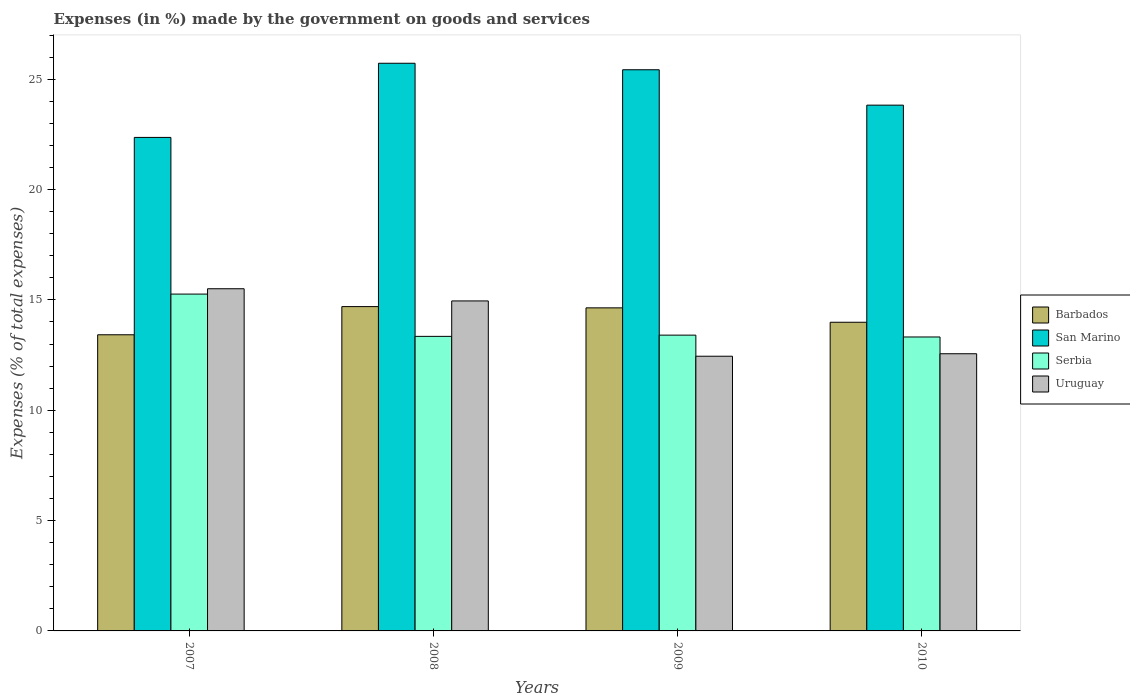How many groups of bars are there?
Keep it short and to the point. 4. Are the number of bars per tick equal to the number of legend labels?
Give a very brief answer. Yes. How many bars are there on the 3rd tick from the right?
Make the answer very short. 4. What is the percentage of expenses made by the government on goods and services in Uruguay in 2008?
Your response must be concise. 14.95. Across all years, what is the maximum percentage of expenses made by the government on goods and services in Serbia?
Offer a very short reply. 15.26. Across all years, what is the minimum percentage of expenses made by the government on goods and services in Uruguay?
Provide a short and direct response. 12.45. In which year was the percentage of expenses made by the government on goods and services in Uruguay maximum?
Ensure brevity in your answer.  2007. What is the total percentage of expenses made by the government on goods and services in Uruguay in the graph?
Your response must be concise. 55.46. What is the difference between the percentage of expenses made by the government on goods and services in San Marino in 2008 and that in 2010?
Offer a terse response. 1.9. What is the difference between the percentage of expenses made by the government on goods and services in Uruguay in 2008 and the percentage of expenses made by the government on goods and services in Barbados in 2007?
Offer a terse response. 1.53. What is the average percentage of expenses made by the government on goods and services in Serbia per year?
Make the answer very short. 13.83. In the year 2009, what is the difference between the percentage of expenses made by the government on goods and services in Uruguay and percentage of expenses made by the government on goods and services in Serbia?
Your response must be concise. -0.96. What is the ratio of the percentage of expenses made by the government on goods and services in San Marino in 2008 to that in 2009?
Keep it short and to the point. 1.01. What is the difference between the highest and the second highest percentage of expenses made by the government on goods and services in Barbados?
Make the answer very short. 0.06. What is the difference between the highest and the lowest percentage of expenses made by the government on goods and services in Barbados?
Your answer should be very brief. 1.28. In how many years, is the percentage of expenses made by the government on goods and services in Uruguay greater than the average percentage of expenses made by the government on goods and services in Uruguay taken over all years?
Provide a succinct answer. 2. Is the sum of the percentage of expenses made by the government on goods and services in Serbia in 2009 and 2010 greater than the maximum percentage of expenses made by the government on goods and services in Uruguay across all years?
Offer a very short reply. Yes. What does the 2nd bar from the left in 2007 represents?
Offer a terse response. San Marino. What does the 3rd bar from the right in 2009 represents?
Provide a short and direct response. San Marino. Is it the case that in every year, the sum of the percentage of expenses made by the government on goods and services in Serbia and percentage of expenses made by the government on goods and services in San Marino is greater than the percentage of expenses made by the government on goods and services in Barbados?
Make the answer very short. Yes. How many bars are there?
Your answer should be very brief. 16. Are all the bars in the graph horizontal?
Provide a succinct answer. No. How many years are there in the graph?
Offer a very short reply. 4. Where does the legend appear in the graph?
Offer a terse response. Center right. What is the title of the graph?
Provide a succinct answer. Expenses (in %) made by the government on goods and services. Does "Zambia" appear as one of the legend labels in the graph?
Make the answer very short. No. What is the label or title of the X-axis?
Keep it short and to the point. Years. What is the label or title of the Y-axis?
Provide a short and direct response. Expenses (% of total expenses). What is the Expenses (% of total expenses) in Barbados in 2007?
Provide a succinct answer. 13.42. What is the Expenses (% of total expenses) in San Marino in 2007?
Make the answer very short. 22.36. What is the Expenses (% of total expenses) in Serbia in 2007?
Your response must be concise. 15.26. What is the Expenses (% of total expenses) of Uruguay in 2007?
Offer a very short reply. 15.5. What is the Expenses (% of total expenses) in Barbados in 2008?
Offer a terse response. 14.69. What is the Expenses (% of total expenses) in San Marino in 2008?
Your response must be concise. 25.72. What is the Expenses (% of total expenses) of Serbia in 2008?
Keep it short and to the point. 13.35. What is the Expenses (% of total expenses) of Uruguay in 2008?
Offer a very short reply. 14.95. What is the Expenses (% of total expenses) in Barbados in 2009?
Your answer should be very brief. 14.64. What is the Expenses (% of total expenses) in San Marino in 2009?
Offer a terse response. 25.43. What is the Expenses (% of total expenses) in Serbia in 2009?
Offer a terse response. 13.4. What is the Expenses (% of total expenses) in Uruguay in 2009?
Provide a succinct answer. 12.45. What is the Expenses (% of total expenses) in Barbados in 2010?
Give a very brief answer. 13.99. What is the Expenses (% of total expenses) in San Marino in 2010?
Provide a short and direct response. 23.82. What is the Expenses (% of total expenses) of Serbia in 2010?
Your answer should be compact. 13.32. What is the Expenses (% of total expenses) of Uruguay in 2010?
Offer a very short reply. 12.56. Across all years, what is the maximum Expenses (% of total expenses) of Barbados?
Offer a terse response. 14.69. Across all years, what is the maximum Expenses (% of total expenses) of San Marino?
Offer a terse response. 25.72. Across all years, what is the maximum Expenses (% of total expenses) of Serbia?
Provide a short and direct response. 15.26. Across all years, what is the maximum Expenses (% of total expenses) in Uruguay?
Provide a succinct answer. 15.5. Across all years, what is the minimum Expenses (% of total expenses) of Barbados?
Your answer should be very brief. 13.42. Across all years, what is the minimum Expenses (% of total expenses) in San Marino?
Your answer should be very brief. 22.36. Across all years, what is the minimum Expenses (% of total expenses) of Serbia?
Your answer should be very brief. 13.32. Across all years, what is the minimum Expenses (% of total expenses) in Uruguay?
Ensure brevity in your answer.  12.45. What is the total Expenses (% of total expenses) of Barbados in the graph?
Make the answer very short. 56.74. What is the total Expenses (% of total expenses) in San Marino in the graph?
Offer a very short reply. 97.33. What is the total Expenses (% of total expenses) in Serbia in the graph?
Provide a succinct answer. 55.33. What is the total Expenses (% of total expenses) of Uruguay in the graph?
Your answer should be compact. 55.46. What is the difference between the Expenses (% of total expenses) in Barbados in 2007 and that in 2008?
Ensure brevity in your answer.  -1.28. What is the difference between the Expenses (% of total expenses) of San Marino in 2007 and that in 2008?
Your response must be concise. -3.36. What is the difference between the Expenses (% of total expenses) of Serbia in 2007 and that in 2008?
Give a very brief answer. 1.92. What is the difference between the Expenses (% of total expenses) of Uruguay in 2007 and that in 2008?
Give a very brief answer. 0.55. What is the difference between the Expenses (% of total expenses) in Barbados in 2007 and that in 2009?
Provide a short and direct response. -1.22. What is the difference between the Expenses (% of total expenses) of San Marino in 2007 and that in 2009?
Your answer should be very brief. -3.07. What is the difference between the Expenses (% of total expenses) of Serbia in 2007 and that in 2009?
Provide a succinct answer. 1.86. What is the difference between the Expenses (% of total expenses) of Uruguay in 2007 and that in 2009?
Provide a short and direct response. 3.06. What is the difference between the Expenses (% of total expenses) in Barbados in 2007 and that in 2010?
Offer a terse response. -0.57. What is the difference between the Expenses (% of total expenses) of San Marino in 2007 and that in 2010?
Offer a terse response. -1.46. What is the difference between the Expenses (% of total expenses) of Serbia in 2007 and that in 2010?
Give a very brief answer. 1.94. What is the difference between the Expenses (% of total expenses) of Uruguay in 2007 and that in 2010?
Ensure brevity in your answer.  2.95. What is the difference between the Expenses (% of total expenses) of Barbados in 2008 and that in 2009?
Ensure brevity in your answer.  0.06. What is the difference between the Expenses (% of total expenses) of San Marino in 2008 and that in 2009?
Provide a short and direct response. 0.29. What is the difference between the Expenses (% of total expenses) in Serbia in 2008 and that in 2009?
Ensure brevity in your answer.  -0.06. What is the difference between the Expenses (% of total expenses) of Uruguay in 2008 and that in 2009?
Your answer should be compact. 2.51. What is the difference between the Expenses (% of total expenses) of Barbados in 2008 and that in 2010?
Make the answer very short. 0.71. What is the difference between the Expenses (% of total expenses) of San Marino in 2008 and that in 2010?
Provide a short and direct response. 1.9. What is the difference between the Expenses (% of total expenses) of Serbia in 2008 and that in 2010?
Provide a short and direct response. 0.03. What is the difference between the Expenses (% of total expenses) of Uruguay in 2008 and that in 2010?
Offer a very short reply. 2.39. What is the difference between the Expenses (% of total expenses) in Barbados in 2009 and that in 2010?
Offer a terse response. 0.65. What is the difference between the Expenses (% of total expenses) in San Marino in 2009 and that in 2010?
Your answer should be compact. 1.6. What is the difference between the Expenses (% of total expenses) of Serbia in 2009 and that in 2010?
Make the answer very short. 0.08. What is the difference between the Expenses (% of total expenses) in Uruguay in 2009 and that in 2010?
Give a very brief answer. -0.11. What is the difference between the Expenses (% of total expenses) in Barbados in 2007 and the Expenses (% of total expenses) in San Marino in 2008?
Your response must be concise. -12.3. What is the difference between the Expenses (% of total expenses) in Barbados in 2007 and the Expenses (% of total expenses) in Serbia in 2008?
Give a very brief answer. 0.07. What is the difference between the Expenses (% of total expenses) of Barbados in 2007 and the Expenses (% of total expenses) of Uruguay in 2008?
Your answer should be compact. -1.53. What is the difference between the Expenses (% of total expenses) of San Marino in 2007 and the Expenses (% of total expenses) of Serbia in 2008?
Your answer should be compact. 9.01. What is the difference between the Expenses (% of total expenses) of San Marino in 2007 and the Expenses (% of total expenses) of Uruguay in 2008?
Provide a succinct answer. 7.41. What is the difference between the Expenses (% of total expenses) in Serbia in 2007 and the Expenses (% of total expenses) in Uruguay in 2008?
Ensure brevity in your answer.  0.31. What is the difference between the Expenses (% of total expenses) of Barbados in 2007 and the Expenses (% of total expenses) of San Marino in 2009?
Offer a terse response. -12.01. What is the difference between the Expenses (% of total expenses) in Barbados in 2007 and the Expenses (% of total expenses) in Serbia in 2009?
Make the answer very short. 0.02. What is the difference between the Expenses (% of total expenses) in Barbados in 2007 and the Expenses (% of total expenses) in Uruguay in 2009?
Offer a terse response. 0.97. What is the difference between the Expenses (% of total expenses) of San Marino in 2007 and the Expenses (% of total expenses) of Serbia in 2009?
Provide a succinct answer. 8.96. What is the difference between the Expenses (% of total expenses) in San Marino in 2007 and the Expenses (% of total expenses) in Uruguay in 2009?
Give a very brief answer. 9.91. What is the difference between the Expenses (% of total expenses) in Serbia in 2007 and the Expenses (% of total expenses) in Uruguay in 2009?
Your response must be concise. 2.82. What is the difference between the Expenses (% of total expenses) of Barbados in 2007 and the Expenses (% of total expenses) of San Marino in 2010?
Offer a terse response. -10.4. What is the difference between the Expenses (% of total expenses) in Barbados in 2007 and the Expenses (% of total expenses) in Serbia in 2010?
Your response must be concise. 0.1. What is the difference between the Expenses (% of total expenses) of Barbados in 2007 and the Expenses (% of total expenses) of Uruguay in 2010?
Make the answer very short. 0.86. What is the difference between the Expenses (% of total expenses) of San Marino in 2007 and the Expenses (% of total expenses) of Serbia in 2010?
Give a very brief answer. 9.04. What is the difference between the Expenses (% of total expenses) of San Marino in 2007 and the Expenses (% of total expenses) of Uruguay in 2010?
Ensure brevity in your answer.  9.8. What is the difference between the Expenses (% of total expenses) of Serbia in 2007 and the Expenses (% of total expenses) of Uruguay in 2010?
Make the answer very short. 2.7. What is the difference between the Expenses (% of total expenses) of Barbados in 2008 and the Expenses (% of total expenses) of San Marino in 2009?
Your answer should be very brief. -10.73. What is the difference between the Expenses (% of total expenses) in Barbados in 2008 and the Expenses (% of total expenses) in Serbia in 2009?
Give a very brief answer. 1.29. What is the difference between the Expenses (% of total expenses) in Barbados in 2008 and the Expenses (% of total expenses) in Uruguay in 2009?
Provide a succinct answer. 2.25. What is the difference between the Expenses (% of total expenses) in San Marino in 2008 and the Expenses (% of total expenses) in Serbia in 2009?
Offer a terse response. 12.32. What is the difference between the Expenses (% of total expenses) in San Marino in 2008 and the Expenses (% of total expenses) in Uruguay in 2009?
Provide a succinct answer. 13.27. What is the difference between the Expenses (% of total expenses) in Serbia in 2008 and the Expenses (% of total expenses) in Uruguay in 2009?
Provide a short and direct response. 0.9. What is the difference between the Expenses (% of total expenses) of Barbados in 2008 and the Expenses (% of total expenses) of San Marino in 2010?
Your answer should be very brief. -9.13. What is the difference between the Expenses (% of total expenses) of Barbados in 2008 and the Expenses (% of total expenses) of Serbia in 2010?
Ensure brevity in your answer.  1.38. What is the difference between the Expenses (% of total expenses) in Barbados in 2008 and the Expenses (% of total expenses) in Uruguay in 2010?
Offer a very short reply. 2.14. What is the difference between the Expenses (% of total expenses) in San Marino in 2008 and the Expenses (% of total expenses) in Serbia in 2010?
Your response must be concise. 12.4. What is the difference between the Expenses (% of total expenses) in San Marino in 2008 and the Expenses (% of total expenses) in Uruguay in 2010?
Provide a short and direct response. 13.16. What is the difference between the Expenses (% of total expenses) in Serbia in 2008 and the Expenses (% of total expenses) in Uruguay in 2010?
Offer a terse response. 0.79. What is the difference between the Expenses (% of total expenses) of Barbados in 2009 and the Expenses (% of total expenses) of San Marino in 2010?
Make the answer very short. -9.18. What is the difference between the Expenses (% of total expenses) of Barbados in 2009 and the Expenses (% of total expenses) of Serbia in 2010?
Offer a terse response. 1.32. What is the difference between the Expenses (% of total expenses) in Barbados in 2009 and the Expenses (% of total expenses) in Uruguay in 2010?
Your answer should be compact. 2.08. What is the difference between the Expenses (% of total expenses) of San Marino in 2009 and the Expenses (% of total expenses) of Serbia in 2010?
Ensure brevity in your answer.  12.11. What is the difference between the Expenses (% of total expenses) of San Marino in 2009 and the Expenses (% of total expenses) of Uruguay in 2010?
Your response must be concise. 12.87. What is the difference between the Expenses (% of total expenses) in Serbia in 2009 and the Expenses (% of total expenses) in Uruguay in 2010?
Provide a succinct answer. 0.84. What is the average Expenses (% of total expenses) of Barbados per year?
Your answer should be very brief. 14.18. What is the average Expenses (% of total expenses) in San Marino per year?
Your answer should be compact. 24.33. What is the average Expenses (% of total expenses) in Serbia per year?
Make the answer very short. 13.83. What is the average Expenses (% of total expenses) in Uruguay per year?
Your answer should be compact. 13.87. In the year 2007, what is the difference between the Expenses (% of total expenses) of Barbados and Expenses (% of total expenses) of San Marino?
Keep it short and to the point. -8.94. In the year 2007, what is the difference between the Expenses (% of total expenses) of Barbados and Expenses (% of total expenses) of Serbia?
Make the answer very short. -1.84. In the year 2007, what is the difference between the Expenses (% of total expenses) in Barbados and Expenses (% of total expenses) in Uruguay?
Make the answer very short. -2.09. In the year 2007, what is the difference between the Expenses (% of total expenses) in San Marino and Expenses (% of total expenses) in Serbia?
Provide a succinct answer. 7.1. In the year 2007, what is the difference between the Expenses (% of total expenses) in San Marino and Expenses (% of total expenses) in Uruguay?
Offer a terse response. 6.86. In the year 2007, what is the difference between the Expenses (% of total expenses) in Serbia and Expenses (% of total expenses) in Uruguay?
Give a very brief answer. -0.24. In the year 2008, what is the difference between the Expenses (% of total expenses) in Barbados and Expenses (% of total expenses) in San Marino?
Your response must be concise. -11.03. In the year 2008, what is the difference between the Expenses (% of total expenses) of Barbados and Expenses (% of total expenses) of Serbia?
Your answer should be very brief. 1.35. In the year 2008, what is the difference between the Expenses (% of total expenses) of Barbados and Expenses (% of total expenses) of Uruguay?
Your answer should be compact. -0.26. In the year 2008, what is the difference between the Expenses (% of total expenses) of San Marino and Expenses (% of total expenses) of Serbia?
Offer a very short reply. 12.37. In the year 2008, what is the difference between the Expenses (% of total expenses) of San Marino and Expenses (% of total expenses) of Uruguay?
Ensure brevity in your answer.  10.77. In the year 2008, what is the difference between the Expenses (% of total expenses) of Serbia and Expenses (% of total expenses) of Uruguay?
Ensure brevity in your answer.  -1.61. In the year 2009, what is the difference between the Expenses (% of total expenses) in Barbados and Expenses (% of total expenses) in San Marino?
Provide a succinct answer. -10.79. In the year 2009, what is the difference between the Expenses (% of total expenses) in Barbados and Expenses (% of total expenses) in Serbia?
Your response must be concise. 1.24. In the year 2009, what is the difference between the Expenses (% of total expenses) of Barbados and Expenses (% of total expenses) of Uruguay?
Your answer should be very brief. 2.19. In the year 2009, what is the difference between the Expenses (% of total expenses) of San Marino and Expenses (% of total expenses) of Serbia?
Your answer should be very brief. 12.02. In the year 2009, what is the difference between the Expenses (% of total expenses) in San Marino and Expenses (% of total expenses) in Uruguay?
Provide a succinct answer. 12.98. In the year 2009, what is the difference between the Expenses (% of total expenses) in Serbia and Expenses (% of total expenses) in Uruguay?
Offer a terse response. 0.96. In the year 2010, what is the difference between the Expenses (% of total expenses) of Barbados and Expenses (% of total expenses) of San Marino?
Provide a short and direct response. -9.84. In the year 2010, what is the difference between the Expenses (% of total expenses) in Barbados and Expenses (% of total expenses) in Serbia?
Give a very brief answer. 0.67. In the year 2010, what is the difference between the Expenses (% of total expenses) in Barbados and Expenses (% of total expenses) in Uruguay?
Provide a succinct answer. 1.43. In the year 2010, what is the difference between the Expenses (% of total expenses) in San Marino and Expenses (% of total expenses) in Serbia?
Your response must be concise. 10.5. In the year 2010, what is the difference between the Expenses (% of total expenses) in San Marino and Expenses (% of total expenses) in Uruguay?
Your answer should be very brief. 11.26. In the year 2010, what is the difference between the Expenses (% of total expenses) in Serbia and Expenses (% of total expenses) in Uruguay?
Offer a terse response. 0.76. What is the ratio of the Expenses (% of total expenses) in Barbados in 2007 to that in 2008?
Provide a short and direct response. 0.91. What is the ratio of the Expenses (% of total expenses) in San Marino in 2007 to that in 2008?
Your response must be concise. 0.87. What is the ratio of the Expenses (% of total expenses) in Serbia in 2007 to that in 2008?
Your response must be concise. 1.14. What is the ratio of the Expenses (% of total expenses) in Uruguay in 2007 to that in 2008?
Make the answer very short. 1.04. What is the ratio of the Expenses (% of total expenses) of San Marino in 2007 to that in 2009?
Your answer should be very brief. 0.88. What is the ratio of the Expenses (% of total expenses) in Serbia in 2007 to that in 2009?
Provide a succinct answer. 1.14. What is the ratio of the Expenses (% of total expenses) of Uruguay in 2007 to that in 2009?
Give a very brief answer. 1.25. What is the ratio of the Expenses (% of total expenses) of Barbados in 2007 to that in 2010?
Provide a succinct answer. 0.96. What is the ratio of the Expenses (% of total expenses) of San Marino in 2007 to that in 2010?
Give a very brief answer. 0.94. What is the ratio of the Expenses (% of total expenses) of Serbia in 2007 to that in 2010?
Your answer should be compact. 1.15. What is the ratio of the Expenses (% of total expenses) in Uruguay in 2007 to that in 2010?
Offer a very short reply. 1.23. What is the ratio of the Expenses (% of total expenses) of San Marino in 2008 to that in 2009?
Your response must be concise. 1.01. What is the ratio of the Expenses (% of total expenses) in Uruguay in 2008 to that in 2009?
Your answer should be compact. 1.2. What is the ratio of the Expenses (% of total expenses) in Barbados in 2008 to that in 2010?
Make the answer very short. 1.05. What is the ratio of the Expenses (% of total expenses) of San Marino in 2008 to that in 2010?
Keep it short and to the point. 1.08. What is the ratio of the Expenses (% of total expenses) in Serbia in 2008 to that in 2010?
Your answer should be very brief. 1. What is the ratio of the Expenses (% of total expenses) in Uruguay in 2008 to that in 2010?
Provide a short and direct response. 1.19. What is the ratio of the Expenses (% of total expenses) of Barbados in 2009 to that in 2010?
Your answer should be compact. 1.05. What is the ratio of the Expenses (% of total expenses) of San Marino in 2009 to that in 2010?
Provide a succinct answer. 1.07. What is the ratio of the Expenses (% of total expenses) in Serbia in 2009 to that in 2010?
Provide a succinct answer. 1.01. What is the difference between the highest and the second highest Expenses (% of total expenses) in Barbados?
Make the answer very short. 0.06. What is the difference between the highest and the second highest Expenses (% of total expenses) of San Marino?
Give a very brief answer. 0.29. What is the difference between the highest and the second highest Expenses (% of total expenses) in Serbia?
Your answer should be very brief. 1.86. What is the difference between the highest and the second highest Expenses (% of total expenses) of Uruguay?
Offer a terse response. 0.55. What is the difference between the highest and the lowest Expenses (% of total expenses) of Barbados?
Provide a succinct answer. 1.28. What is the difference between the highest and the lowest Expenses (% of total expenses) in San Marino?
Keep it short and to the point. 3.36. What is the difference between the highest and the lowest Expenses (% of total expenses) of Serbia?
Give a very brief answer. 1.94. What is the difference between the highest and the lowest Expenses (% of total expenses) of Uruguay?
Keep it short and to the point. 3.06. 